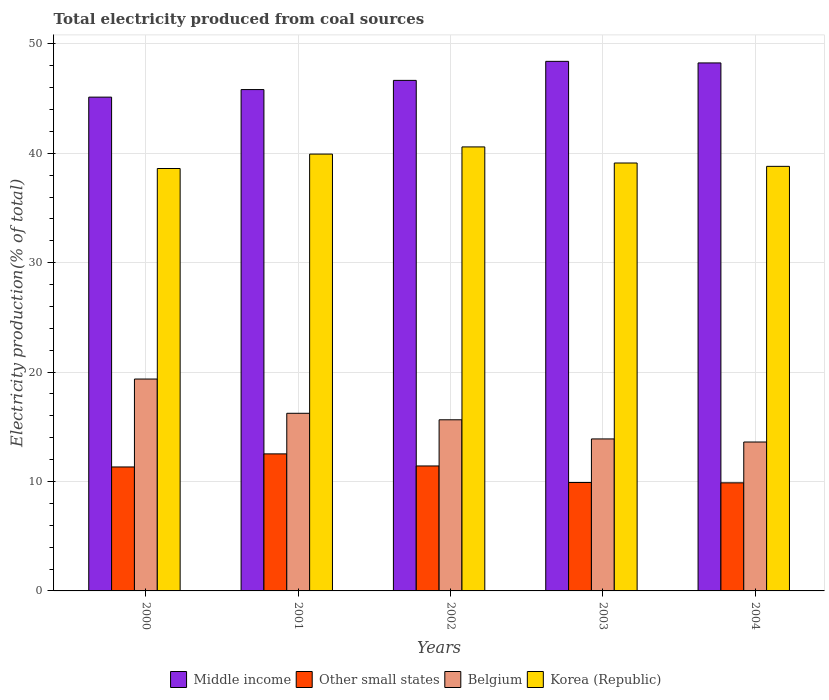How many groups of bars are there?
Give a very brief answer. 5. Are the number of bars per tick equal to the number of legend labels?
Ensure brevity in your answer.  Yes. Are the number of bars on each tick of the X-axis equal?
Offer a terse response. Yes. What is the label of the 5th group of bars from the left?
Provide a succinct answer. 2004. In how many cases, is the number of bars for a given year not equal to the number of legend labels?
Your answer should be compact. 0. What is the total electricity produced in Korea (Republic) in 2001?
Provide a succinct answer. 39.93. Across all years, what is the maximum total electricity produced in Korea (Republic)?
Make the answer very short. 40.58. Across all years, what is the minimum total electricity produced in Korea (Republic)?
Give a very brief answer. 38.61. In which year was the total electricity produced in Korea (Republic) maximum?
Provide a short and direct response. 2002. What is the total total electricity produced in Korea (Republic) in the graph?
Provide a succinct answer. 197.03. What is the difference between the total electricity produced in Middle income in 2003 and that in 2004?
Ensure brevity in your answer.  0.14. What is the difference between the total electricity produced in Korea (Republic) in 2000 and the total electricity produced in Other small states in 2003?
Provide a short and direct response. 28.7. What is the average total electricity produced in Middle income per year?
Provide a short and direct response. 46.85. In the year 2002, what is the difference between the total electricity produced in Belgium and total electricity produced in Middle income?
Provide a short and direct response. -31.02. What is the ratio of the total electricity produced in Korea (Republic) in 2000 to that in 2004?
Offer a terse response. 0.99. Is the difference between the total electricity produced in Belgium in 2000 and 2004 greater than the difference between the total electricity produced in Middle income in 2000 and 2004?
Keep it short and to the point. Yes. What is the difference between the highest and the second highest total electricity produced in Korea (Republic)?
Give a very brief answer. 0.65. What is the difference between the highest and the lowest total electricity produced in Belgium?
Offer a terse response. 5.76. In how many years, is the total electricity produced in Other small states greater than the average total electricity produced in Other small states taken over all years?
Offer a terse response. 3. Is the sum of the total electricity produced in Belgium in 2001 and 2003 greater than the maximum total electricity produced in Korea (Republic) across all years?
Your response must be concise. No. What does the 3rd bar from the left in 2002 represents?
Offer a very short reply. Belgium. What does the 1st bar from the right in 2003 represents?
Provide a short and direct response. Korea (Republic). How many bars are there?
Your response must be concise. 20. What is the difference between two consecutive major ticks on the Y-axis?
Offer a very short reply. 10. Does the graph contain any zero values?
Your response must be concise. No. What is the title of the graph?
Keep it short and to the point. Total electricity produced from coal sources. Does "Finland" appear as one of the legend labels in the graph?
Your answer should be very brief. No. What is the label or title of the X-axis?
Give a very brief answer. Years. What is the label or title of the Y-axis?
Your answer should be very brief. Electricity production(% of total). What is the Electricity production(% of total) in Middle income in 2000?
Provide a short and direct response. 45.13. What is the Electricity production(% of total) of Other small states in 2000?
Ensure brevity in your answer.  11.33. What is the Electricity production(% of total) of Belgium in 2000?
Provide a succinct answer. 19.37. What is the Electricity production(% of total) in Korea (Republic) in 2000?
Keep it short and to the point. 38.61. What is the Electricity production(% of total) in Middle income in 2001?
Give a very brief answer. 45.82. What is the Electricity production(% of total) in Other small states in 2001?
Offer a very short reply. 12.52. What is the Electricity production(% of total) in Belgium in 2001?
Ensure brevity in your answer.  16.24. What is the Electricity production(% of total) of Korea (Republic) in 2001?
Offer a terse response. 39.93. What is the Electricity production(% of total) in Middle income in 2002?
Give a very brief answer. 46.66. What is the Electricity production(% of total) in Other small states in 2002?
Offer a terse response. 11.42. What is the Electricity production(% of total) of Belgium in 2002?
Provide a short and direct response. 15.64. What is the Electricity production(% of total) in Korea (Republic) in 2002?
Your response must be concise. 40.58. What is the Electricity production(% of total) of Middle income in 2003?
Provide a short and direct response. 48.4. What is the Electricity production(% of total) in Other small states in 2003?
Ensure brevity in your answer.  9.91. What is the Electricity production(% of total) of Belgium in 2003?
Offer a very short reply. 13.89. What is the Electricity production(% of total) of Korea (Republic) in 2003?
Your response must be concise. 39.11. What is the Electricity production(% of total) of Middle income in 2004?
Your response must be concise. 48.26. What is the Electricity production(% of total) of Other small states in 2004?
Your answer should be compact. 9.88. What is the Electricity production(% of total) of Belgium in 2004?
Offer a very short reply. 13.61. What is the Electricity production(% of total) in Korea (Republic) in 2004?
Your answer should be very brief. 38.8. Across all years, what is the maximum Electricity production(% of total) in Middle income?
Your answer should be compact. 48.4. Across all years, what is the maximum Electricity production(% of total) in Other small states?
Your answer should be very brief. 12.52. Across all years, what is the maximum Electricity production(% of total) of Belgium?
Your answer should be very brief. 19.37. Across all years, what is the maximum Electricity production(% of total) of Korea (Republic)?
Give a very brief answer. 40.58. Across all years, what is the minimum Electricity production(% of total) of Middle income?
Make the answer very short. 45.13. Across all years, what is the minimum Electricity production(% of total) of Other small states?
Offer a very short reply. 9.88. Across all years, what is the minimum Electricity production(% of total) in Belgium?
Ensure brevity in your answer.  13.61. Across all years, what is the minimum Electricity production(% of total) in Korea (Republic)?
Offer a very short reply. 38.61. What is the total Electricity production(% of total) in Middle income in the graph?
Offer a terse response. 234.27. What is the total Electricity production(% of total) in Other small states in the graph?
Your response must be concise. 55.06. What is the total Electricity production(% of total) of Belgium in the graph?
Keep it short and to the point. 78.75. What is the total Electricity production(% of total) of Korea (Republic) in the graph?
Your answer should be very brief. 197.03. What is the difference between the Electricity production(% of total) in Middle income in 2000 and that in 2001?
Keep it short and to the point. -0.69. What is the difference between the Electricity production(% of total) of Other small states in 2000 and that in 2001?
Your answer should be very brief. -1.2. What is the difference between the Electricity production(% of total) of Belgium in 2000 and that in 2001?
Offer a terse response. 3.13. What is the difference between the Electricity production(% of total) in Korea (Republic) in 2000 and that in 2001?
Give a very brief answer. -1.32. What is the difference between the Electricity production(% of total) of Middle income in 2000 and that in 2002?
Your answer should be very brief. -1.53. What is the difference between the Electricity production(% of total) in Other small states in 2000 and that in 2002?
Provide a short and direct response. -0.09. What is the difference between the Electricity production(% of total) in Belgium in 2000 and that in 2002?
Offer a very short reply. 3.72. What is the difference between the Electricity production(% of total) of Korea (Republic) in 2000 and that in 2002?
Provide a succinct answer. -1.97. What is the difference between the Electricity production(% of total) in Middle income in 2000 and that in 2003?
Offer a very short reply. -3.27. What is the difference between the Electricity production(% of total) of Other small states in 2000 and that in 2003?
Provide a succinct answer. 1.42. What is the difference between the Electricity production(% of total) in Belgium in 2000 and that in 2003?
Ensure brevity in your answer.  5.47. What is the difference between the Electricity production(% of total) of Korea (Republic) in 2000 and that in 2003?
Offer a terse response. -0.5. What is the difference between the Electricity production(% of total) of Middle income in 2000 and that in 2004?
Give a very brief answer. -3.13. What is the difference between the Electricity production(% of total) of Other small states in 2000 and that in 2004?
Ensure brevity in your answer.  1.45. What is the difference between the Electricity production(% of total) in Belgium in 2000 and that in 2004?
Provide a succinct answer. 5.76. What is the difference between the Electricity production(% of total) in Korea (Republic) in 2000 and that in 2004?
Offer a very short reply. -0.2. What is the difference between the Electricity production(% of total) in Middle income in 2001 and that in 2002?
Provide a short and direct response. -0.84. What is the difference between the Electricity production(% of total) in Other small states in 2001 and that in 2002?
Give a very brief answer. 1.1. What is the difference between the Electricity production(% of total) of Belgium in 2001 and that in 2002?
Keep it short and to the point. 0.59. What is the difference between the Electricity production(% of total) in Korea (Republic) in 2001 and that in 2002?
Provide a short and direct response. -0.65. What is the difference between the Electricity production(% of total) of Middle income in 2001 and that in 2003?
Your response must be concise. -2.58. What is the difference between the Electricity production(% of total) in Other small states in 2001 and that in 2003?
Make the answer very short. 2.62. What is the difference between the Electricity production(% of total) in Belgium in 2001 and that in 2003?
Give a very brief answer. 2.34. What is the difference between the Electricity production(% of total) of Korea (Republic) in 2001 and that in 2003?
Offer a terse response. 0.82. What is the difference between the Electricity production(% of total) of Middle income in 2001 and that in 2004?
Offer a terse response. -2.43. What is the difference between the Electricity production(% of total) of Other small states in 2001 and that in 2004?
Keep it short and to the point. 2.65. What is the difference between the Electricity production(% of total) in Belgium in 2001 and that in 2004?
Ensure brevity in your answer.  2.62. What is the difference between the Electricity production(% of total) in Korea (Republic) in 2001 and that in 2004?
Provide a succinct answer. 1.12. What is the difference between the Electricity production(% of total) in Middle income in 2002 and that in 2003?
Ensure brevity in your answer.  -1.74. What is the difference between the Electricity production(% of total) of Other small states in 2002 and that in 2003?
Provide a succinct answer. 1.51. What is the difference between the Electricity production(% of total) in Belgium in 2002 and that in 2003?
Keep it short and to the point. 1.75. What is the difference between the Electricity production(% of total) of Korea (Republic) in 2002 and that in 2003?
Offer a terse response. 1.47. What is the difference between the Electricity production(% of total) of Middle income in 2002 and that in 2004?
Your response must be concise. -1.6. What is the difference between the Electricity production(% of total) in Other small states in 2002 and that in 2004?
Offer a very short reply. 1.54. What is the difference between the Electricity production(% of total) in Belgium in 2002 and that in 2004?
Provide a short and direct response. 2.03. What is the difference between the Electricity production(% of total) of Korea (Republic) in 2002 and that in 2004?
Provide a succinct answer. 1.78. What is the difference between the Electricity production(% of total) in Middle income in 2003 and that in 2004?
Offer a terse response. 0.14. What is the difference between the Electricity production(% of total) in Other small states in 2003 and that in 2004?
Your answer should be compact. 0.03. What is the difference between the Electricity production(% of total) in Belgium in 2003 and that in 2004?
Your answer should be compact. 0.28. What is the difference between the Electricity production(% of total) of Korea (Republic) in 2003 and that in 2004?
Your response must be concise. 0.31. What is the difference between the Electricity production(% of total) of Middle income in 2000 and the Electricity production(% of total) of Other small states in 2001?
Give a very brief answer. 32.61. What is the difference between the Electricity production(% of total) in Middle income in 2000 and the Electricity production(% of total) in Belgium in 2001?
Ensure brevity in your answer.  28.9. What is the difference between the Electricity production(% of total) of Middle income in 2000 and the Electricity production(% of total) of Korea (Republic) in 2001?
Provide a short and direct response. 5.2. What is the difference between the Electricity production(% of total) of Other small states in 2000 and the Electricity production(% of total) of Belgium in 2001?
Your answer should be very brief. -4.91. What is the difference between the Electricity production(% of total) of Other small states in 2000 and the Electricity production(% of total) of Korea (Republic) in 2001?
Offer a terse response. -28.6. What is the difference between the Electricity production(% of total) of Belgium in 2000 and the Electricity production(% of total) of Korea (Republic) in 2001?
Ensure brevity in your answer.  -20.56. What is the difference between the Electricity production(% of total) of Middle income in 2000 and the Electricity production(% of total) of Other small states in 2002?
Your answer should be compact. 33.71. What is the difference between the Electricity production(% of total) in Middle income in 2000 and the Electricity production(% of total) in Belgium in 2002?
Your answer should be very brief. 29.49. What is the difference between the Electricity production(% of total) in Middle income in 2000 and the Electricity production(% of total) in Korea (Republic) in 2002?
Ensure brevity in your answer.  4.55. What is the difference between the Electricity production(% of total) in Other small states in 2000 and the Electricity production(% of total) in Belgium in 2002?
Keep it short and to the point. -4.31. What is the difference between the Electricity production(% of total) in Other small states in 2000 and the Electricity production(% of total) in Korea (Republic) in 2002?
Your answer should be compact. -29.25. What is the difference between the Electricity production(% of total) in Belgium in 2000 and the Electricity production(% of total) in Korea (Republic) in 2002?
Give a very brief answer. -21.21. What is the difference between the Electricity production(% of total) in Middle income in 2000 and the Electricity production(% of total) in Other small states in 2003?
Ensure brevity in your answer.  35.22. What is the difference between the Electricity production(% of total) in Middle income in 2000 and the Electricity production(% of total) in Belgium in 2003?
Provide a succinct answer. 31.24. What is the difference between the Electricity production(% of total) of Middle income in 2000 and the Electricity production(% of total) of Korea (Republic) in 2003?
Your response must be concise. 6.02. What is the difference between the Electricity production(% of total) of Other small states in 2000 and the Electricity production(% of total) of Belgium in 2003?
Offer a terse response. -2.56. What is the difference between the Electricity production(% of total) in Other small states in 2000 and the Electricity production(% of total) in Korea (Republic) in 2003?
Provide a succinct answer. -27.78. What is the difference between the Electricity production(% of total) in Belgium in 2000 and the Electricity production(% of total) in Korea (Republic) in 2003?
Give a very brief answer. -19.74. What is the difference between the Electricity production(% of total) of Middle income in 2000 and the Electricity production(% of total) of Other small states in 2004?
Offer a terse response. 35.25. What is the difference between the Electricity production(% of total) of Middle income in 2000 and the Electricity production(% of total) of Belgium in 2004?
Offer a very short reply. 31.52. What is the difference between the Electricity production(% of total) of Middle income in 2000 and the Electricity production(% of total) of Korea (Republic) in 2004?
Your answer should be compact. 6.33. What is the difference between the Electricity production(% of total) of Other small states in 2000 and the Electricity production(% of total) of Belgium in 2004?
Give a very brief answer. -2.28. What is the difference between the Electricity production(% of total) in Other small states in 2000 and the Electricity production(% of total) in Korea (Republic) in 2004?
Make the answer very short. -27.48. What is the difference between the Electricity production(% of total) of Belgium in 2000 and the Electricity production(% of total) of Korea (Republic) in 2004?
Ensure brevity in your answer.  -19.44. What is the difference between the Electricity production(% of total) in Middle income in 2001 and the Electricity production(% of total) in Other small states in 2002?
Offer a very short reply. 34.4. What is the difference between the Electricity production(% of total) in Middle income in 2001 and the Electricity production(% of total) in Belgium in 2002?
Offer a very short reply. 30.18. What is the difference between the Electricity production(% of total) of Middle income in 2001 and the Electricity production(% of total) of Korea (Republic) in 2002?
Offer a very short reply. 5.24. What is the difference between the Electricity production(% of total) of Other small states in 2001 and the Electricity production(% of total) of Belgium in 2002?
Your response must be concise. -3.12. What is the difference between the Electricity production(% of total) of Other small states in 2001 and the Electricity production(% of total) of Korea (Republic) in 2002?
Provide a short and direct response. -28.06. What is the difference between the Electricity production(% of total) in Belgium in 2001 and the Electricity production(% of total) in Korea (Republic) in 2002?
Keep it short and to the point. -24.35. What is the difference between the Electricity production(% of total) of Middle income in 2001 and the Electricity production(% of total) of Other small states in 2003?
Keep it short and to the point. 35.91. What is the difference between the Electricity production(% of total) in Middle income in 2001 and the Electricity production(% of total) in Belgium in 2003?
Your answer should be very brief. 31.93. What is the difference between the Electricity production(% of total) in Middle income in 2001 and the Electricity production(% of total) in Korea (Republic) in 2003?
Your answer should be very brief. 6.71. What is the difference between the Electricity production(% of total) of Other small states in 2001 and the Electricity production(% of total) of Belgium in 2003?
Provide a short and direct response. -1.37. What is the difference between the Electricity production(% of total) of Other small states in 2001 and the Electricity production(% of total) of Korea (Republic) in 2003?
Make the answer very short. -26.59. What is the difference between the Electricity production(% of total) of Belgium in 2001 and the Electricity production(% of total) of Korea (Republic) in 2003?
Ensure brevity in your answer.  -22.87. What is the difference between the Electricity production(% of total) of Middle income in 2001 and the Electricity production(% of total) of Other small states in 2004?
Offer a terse response. 35.94. What is the difference between the Electricity production(% of total) of Middle income in 2001 and the Electricity production(% of total) of Belgium in 2004?
Provide a short and direct response. 32.21. What is the difference between the Electricity production(% of total) in Middle income in 2001 and the Electricity production(% of total) in Korea (Republic) in 2004?
Your answer should be very brief. 7.02. What is the difference between the Electricity production(% of total) of Other small states in 2001 and the Electricity production(% of total) of Belgium in 2004?
Provide a short and direct response. -1.09. What is the difference between the Electricity production(% of total) of Other small states in 2001 and the Electricity production(% of total) of Korea (Republic) in 2004?
Your answer should be very brief. -26.28. What is the difference between the Electricity production(% of total) of Belgium in 2001 and the Electricity production(% of total) of Korea (Republic) in 2004?
Provide a short and direct response. -22.57. What is the difference between the Electricity production(% of total) of Middle income in 2002 and the Electricity production(% of total) of Other small states in 2003?
Provide a succinct answer. 36.75. What is the difference between the Electricity production(% of total) in Middle income in 2002 and the Electricity production(% of total) in Belgium in 2003?
Provide a succinct answer. 32.77. What is the difference between the Electricity production(% of total) in Middle income in 2002 and the Electricity production(% of total) in Korea (Republic) in 2003?
Give a very brief answer. 7.55. What is the difference between the Electricity production(% of total) in Other small states in 2002 and the Electricity production(% of total) in Belgium in 2003?
Offer a terse response. -2.47. What is the difference between the Electricity production(% of total) of Other small states in 2002 and the Electricity production(% of total) of Korea (Republic) in 2003?
Make the answer very short. -27.69. What is the difference between the Electricity production(% of total) of Belgium in 2002 and the Electricity production(% of total) of Korea (Republic) in 2003?
Your response must be concise. -23.47. What is the difference between the Electricity production(% of total) of Middle income in 2002 and the Electricity production(% of total) of Other small states in 2004?
Your answer should be very brief. 36.78. What is the difference between the Electricity production(% of total) of Middle income in 2002 and the Electricity production(% of total) of Belgium in 2004?
Ensure brevity in your answer.  33.05. What is the difference between the Electricity production(% of total) of Middle income in 2002 and the Electricity production(% of total) of Korea (Republic) in 2004?
Provide a short and direct response. 7.86. What is the difference between the Electricity production(% of total) of Other small states in 2002 and the Electricity production(% of total) of Belgium in 2004?
Keep it short and to the point. -2.19. What is the difference between the Electricity production(% of total) of Other small states in 2002 and the Electricity production(% of total) of Korea (Republic) in 2004?
Provide a short and direct response. -27.38. What is the difference between the Electricity production(% of total) of Belgium in 2002 and the Electricity production(% of total) of Korea (Republic) in 2004?
Make the answer very short. -23.16. What is the difference between the Electricity production(% of total) in Middle income in 2003 and the Electricity production(% of total) in Other small states in 2004?
Your answer should be compact. 38.52. What is the difference between the Electricity production(% of total) of Middle income in 2003 and the Electricity production(% of total) of Belgium in 2004?
Make the answer very short. 34.79. What is the difference between the Electricity production(% of total) of Middle income in 2003 and the Electricity production(% of total) of Korea (Republic) in 2004?
Provide a short and direct response. 9.6. What is the difference between the Electricity production(% of total) of Other small states in 2003 and the Electricity production(% of total) of Belgium in 2004?
Provide a short and direct response. -3.7. What is the difference between the Electricity production(% of total) in Other small states in 2003 and the Electricity production(% of total) in Korea (Republic) in 2004?
Make the answer very short. -28.9. What is the difference between the Electricity production(% of total) in Belgium in 2003 and the Electricity production(% of total) in Korea (Republic) in 2004?
Give a very brief answer. -24.91. What is the average Electricity production(% of total) in Middle income per year?
Keep it short and to the point. 46.85. What is the average Electricity production(% of total) of Other small states per year?
Your answer should be very brief. 11.01. What is the average Electricity production(% of total) of Belgium per year?
Your answer should be very brief. 15.75. What is the average Electricity production(% of total) of Korea (Republic) per year?
Your answer should be compact. 39.41. In the year 2000, what is the difference between the Electricity production(% of total) of Middle income and Electricity production(% of total) of Other small states?
Keep it short and to the point. 33.8. In the year 2000, what is the difference between the Electricity production(% of total) of Middle income and Electricity production(% of total) of Belgium?
Ensure brevity in your answer.  25.76. In the year 2000, what is the difference between the Electricity production(% of total) of Middle income and Electricity production(% of total) of Korea (Republic)?
Offer a terse response. 6.52. In the year 2000, what is the difference between the Electricity production(% of total) of Other small states and Electricity production(% of total) of Belgium?
Your answer should be very brief. -8.04. In the year 2000, what is the difference between the Electricity production(% of total) in Other small states and Electricity production(% of total) in Korea (Republic)?
Provide a succinct answer. -27.28. In the year 2000, what is the difference between the Electricity production(% of total) of Belgium and Electricity production(% of total) of Korea (Republic)?
Offer a very short reply. -19.24. In the year 2001, what is the difference between the Electricity production(% of total) of Middle income and Electricity production(% of total) of Other small states?
Offer a very short reply. 33.3. In the year 2001, what is the difference between the Electricity production(% of total) of Middle income and Electricity production(% of total) of Belgium?
Your response must be concise. 29.59. In the year 2001, what is the difference between the Electricity production(% of total) in Middle income and Electricity production(% of total) in Korea (Republic)?
Keep it short and to the point. 5.9. In the year 2001, what is the difference between the Electricity production(% of total) of Other small states and Electricity production(% of total) of Belgium?
Provide a succinct answer. -3.71. In the year 2001, what is the difference between the Electricity production(% of total) in Other small states and Electricity production(% of total) in Korea (Republic)?
Your answer should be compact. -27.4. In the year 2001, what is the difference between the Electricity production(% of total) of Belgium and Electricity production(% of total) of Korea (Republic)?
Give a very brief answer. -23.69. In the year 2002, what is the difference between the Electricity production(% of total) of Middle income and Electricity production(% of total) of Other small states?
Your answer should be compact. 35.24. In the year 2002, what is the difference between the Electricity production(% of total) of Middle income and Electricity production(% of total) of Belgium?
Your answer should be very brief. 31.02. In the year 2002, what is the difference between the Electricity production(% of total) in Middle income and Electricity production(% of total) in Korea (Republic)?
Your answer should be very brief. 6.08. In the year 2002, what is the difference between the Electricity production(% of total) in Other small states and Electricity production(% of total) in Belgium?
Provide a short and direct response. -4.22. In the year 2002, what is the difference between the Electricity production(% of total) in Other small states and Electricity production(% of total) in Korea (Republic)?
Offer a terse response. -29.16. In the year 2002, what is the difference between the Electricity production(% of total) in Belgium and Electricity production(% of total) in Korea (Republic)?
Provide a short and direct response. -24.94. In the year 2003, what is the difference between the Electricity production(% of total) of Middle income and Electricity production(% of total) of Other small states?
Your response must be concise. 38.49. In the year 2003, what is the difference between the Electricity production(% of total) of Middle income and Electricity production(% of total) of Belgium?
Offer a very short reply. 34.51. In the year 2003, what is the difference between the Electricity production(% of total) of Middle income and Electricity production(% of total) of Korea (Republic)?
Make the answer very short. 9.29. In the year 2003, what is the difference between the Electricity production(% of total) in Other small states and Electricity production(% of total) in Belgium?
Make the answer very short. -3.98. In the year 2003, what is the difference between the Electricity production(% of total) of Other small states and Electricity production(% of total) of Korea (Republic)?
Provide a short and direct response. -29.2. In the year 2003, what is the difference between the Electricity production(% of total) in Belgium and Electricity production(% of total) in Korea (Republic)?
Make the answer very short. -25.22. In the year 2004, what is the difference between the Electricity production(% of total) in Middle income and Electricity production(% of total) in Other small states?
Make the answer very short. 38.38. In the year 2004, what is the difference between the Electricity production(% of total) of Middle income and Electricity production(% of total) of Belgium?
Provide a succinct answer. 34.65. In the year 2004, what is the difference between the Electricity production(% of total) in Middle income and Electricity production(% of total) in Korea (Republic)?
Your answer should be very brief. 9.45. In the year 2004, what is the difference between the Electricity production(% of total) in Other small states and Electricity production(% of total) in Belgium?
Keep it short and to the point. -3.73. In the year 2004, what is the difference between the Electricity production(% of total) in Other small states and Electricity production(% of total) in Korea (Republic)?
Provide a succinct answer. -28.93. In the year 2004, what is the difference between the Electricity production(% of total) in Belgium and Electricity production(% of total) in Korea (Republic)?
Offer a very short reply. -25.19. What is the ratio of the Electricity production(% of total) in Middle income in 2000 to that in 2001?
Your answer should be very brief. 0.98. What is the ratio of the Electricity production(% of total) of Other small states in 2000 to that in 2001?
Ensure brevity in your answer.  0.9. What is the ratio of the Electricity production(% of total) of Belgium in 2000 to that in 2001?
Your response must be concise. 1.19. What is the ratio of the Electricity production(% of total) in Middle income in 2000 to that in 2002?
Keep it short and to the point. 0.97. What is the ratio of the Electricity production(% of total) in Belgium in 2000 to that in 2002?
Make the answer very short. 1.24. What is the ratio of the Electricity production(% of total) of Korea (Republic) in 2000 to that in 2002?
Offer a terse response. 0.95. What is the ratio of the Electricity production(% of total) in Middle income in 2000 to that in 2003?
Offer a terse response. 0.93. What is the ratio of the Electricity production(% of total) in Other small states in 2000 to that in 2003?
Your response must be concise. 1.14. What is the ratio of the Electricity production(% of total) in Belgium in 2000 to that in 2003?
Offer a very short reply. 1.39. What is the ratio of the Electricity production(% of total) of Korea (Republic) in 2000 to that in 2003?
Keep it short and to the point. 0.99. What is the ratio of the Electricity production(% of total) of Middle income in 2000 to that in 2004?
Offer a terse response. 0.94. What is the ratio of the Electricity production(% of total) of Other small states in 2000 to that in 2004?
Your answer should be compact. 1.15. What is the ratio of the Electricity production(% of total) of Belgium in 2000 to that in 2004?
Your answer should be very brief. 1.42. What is the ratio of the Electricity production(% of total) of Korea (Republic) in 2000 to that in 2004?
Offer a very short reply. 0.99. What is the ratio of the Electricity production(% of total) in Other small states in 2001 to that in 2002?
Your answer should be very brief. 1.1. What is the ratio of the Electricity production(% of total) of Belgium in 2001 to that in 2002?
Provide a succinct answer. 1.04. What is the ratio of the Electricity production(% of total) of Korea (Republic) in 2001 to that in 2002?
Your answer should be very brief. 0.98. What is the ratio of the Electricity production(% of total) in Middle income in 2001 to that in 2003?
Keep it short and to the point. 0.95. What is the ratio of the Electricity production(% of total) of Other small states in 2001 to that in 2003?
Make the answer very short. 1.26. What is the ratio of the Electricity production(% of total) of Belgium in 2001 to that in 2003?
Your answer should be very brief. 1.17. What is the ratio of the Electricity production(% of total) in Korea (Republic) in 2001 to that in 2003?
Your answer should be very brief. 1.02. What is the ratio of the Electricity production(% of total) in Middle income in 2001 to that in 2004?
Your response must be concise. 0.95. What is the ratio of the Electricity production(% of total) in Other small states in 2001 to that in 2004?
Your response must be concise. 1.27. What is the ratio of the Electricity production(% of total) of Belgium in 2001 to that in 2004?
Your response must be concise. 1.19. What is the ratio of the Electricity production(% of total) in Korea (Republic) in 2001 to that in 2004?
Offer a terse response. 1.03. What is the ratio of the Electricity production(% of total) in Middle income in 2002 to that in 2003?
Ensure brevity in your answer.  0.96. What is the ratio of the Electricity production(% of total) in Other small states in 2002 to that in 2003?
Your answer should be very brief. 1.15. What is the ratio of the Electricity production(% of total) of Belgium in 2002 to that in 2003?
Your response must be concise. 1.13. What is the ratio of the Electricity production(% of total) of Korea (Republic) in 2002 to that in 2003?
Offer a very short reply. 1.04. What is the ratio of the Electricity production(% of total) in Middle income in 2002 to that in 2004?
Your response must be concise. 0.97. What is the ratio of the Electricity production(% of total) in Other small states in 2002 to that in 2004?
Your answer should be very brief. 1.16. What is the ratio of the Electricity production(% of total) in Belgium in 2002 to that in 2004?
Make the answer very short. 1.15. What is the ratio of the Electricity production(% of total) of Korea (Republic) in 2002 to that in 2004?
Offer a terse response. 1.05. What is the ratio of the Electricity production(% of total) of Belgium in 2003 to that in 2004?
Make the answer very short. 1.02. What is the ratio of the Electricity production(% of total) in Korea (Republic) in 2003 to that in 2004?
Provide a short and direct response. 1.01. What is the difference between the highest and the second highest Electricity production(% of total) of Middle income?
Make the answer very short. 0.14. What is the difference between the highest and the second highest Electricity production(% of total) of Other small states?
Ensure brevity in your answer.  1.1. What is the difference between the highest and the second highest Electricity production(% of total) in Belgium?
Offer a very short reply. 3.13. What is the difference between the highest and the second highest Electricity production(% of total) of Korea (Republic)?
Offer a very short reply. 0.65. What is the difference between the highest and the lowest Electricity production(% of total) of Middle income?
Offer a very short reply. 3.27. What is the difference between the highest and the lowest Electricity production(% of total) in Other small states?
Provide a short and direct response. 2.65. What is the difference between the highest and the lowest Electricity production(% of total) of Belgium?
Keep it short and to the point. 5.76. What is the difference between the highest and the lowest Electricity production(% of total) of Korea (Republic)?
Ensure brevity in your answer.  1.97. 